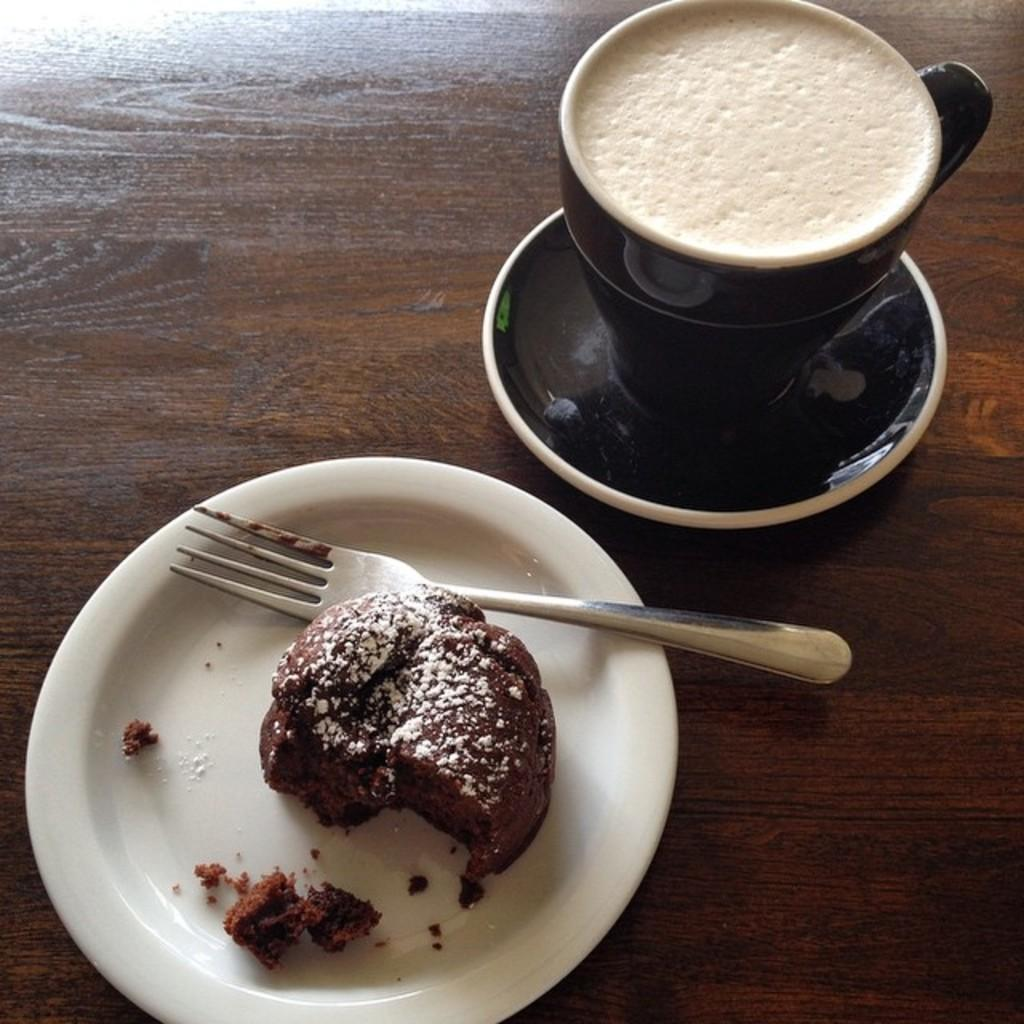What type of surface is visible in the image? There is a wooden surface in the image. What is placed on the wooden surface? There is a plate on the wooden surface, and it contains a piece of cake. What utensil is present on the wooden surface? There is a fork on the wooden surface. What else is on the wooden surface besides the plate and fork? There is a saucer on the wooden surface, and it contains a cup of tea. How many cats are sitting on the wooden surface in the image? There are no cats present in the image; it features a plate of cake, a fork, a saucer, and a cup of tea on a wooden surface. 